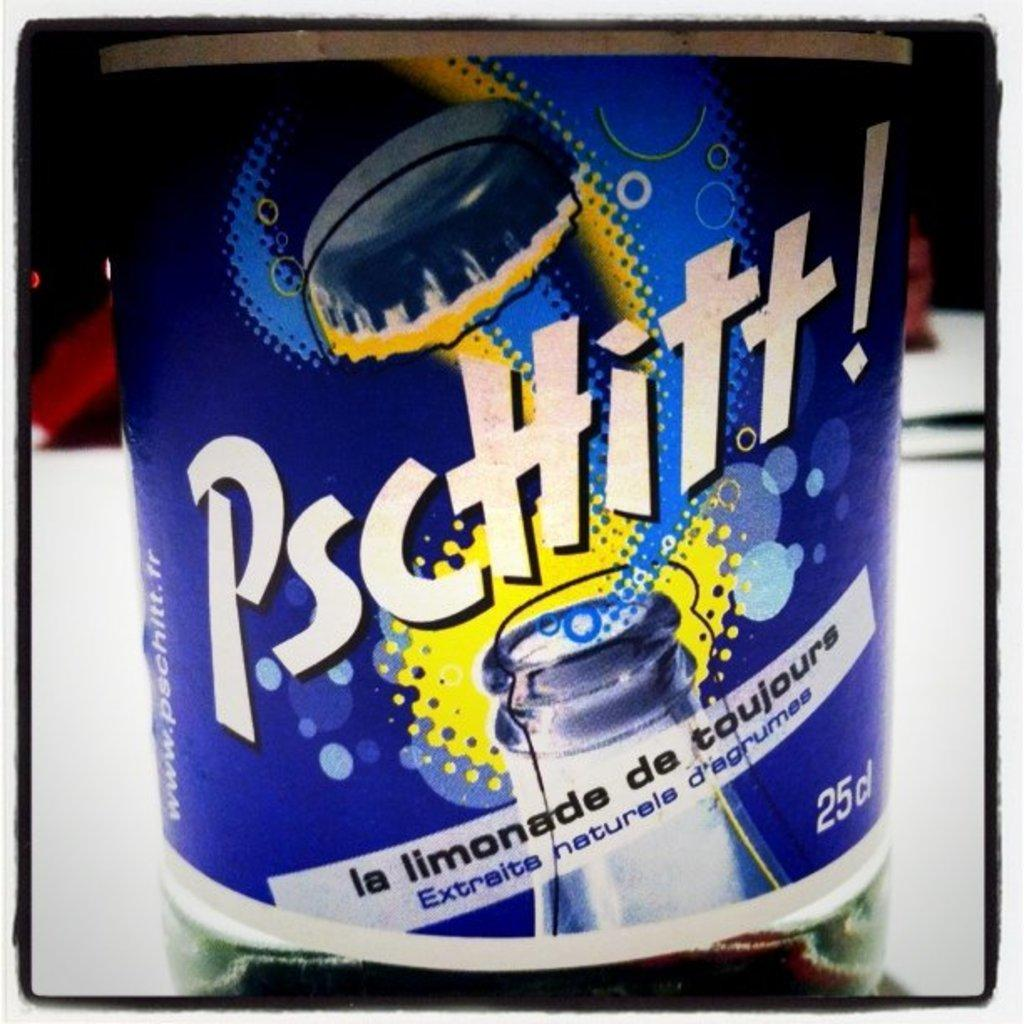Provide a one-sentence caption for the provided image. A bottle of some type of beverage with the text, Pscttitt!, written on the front. 